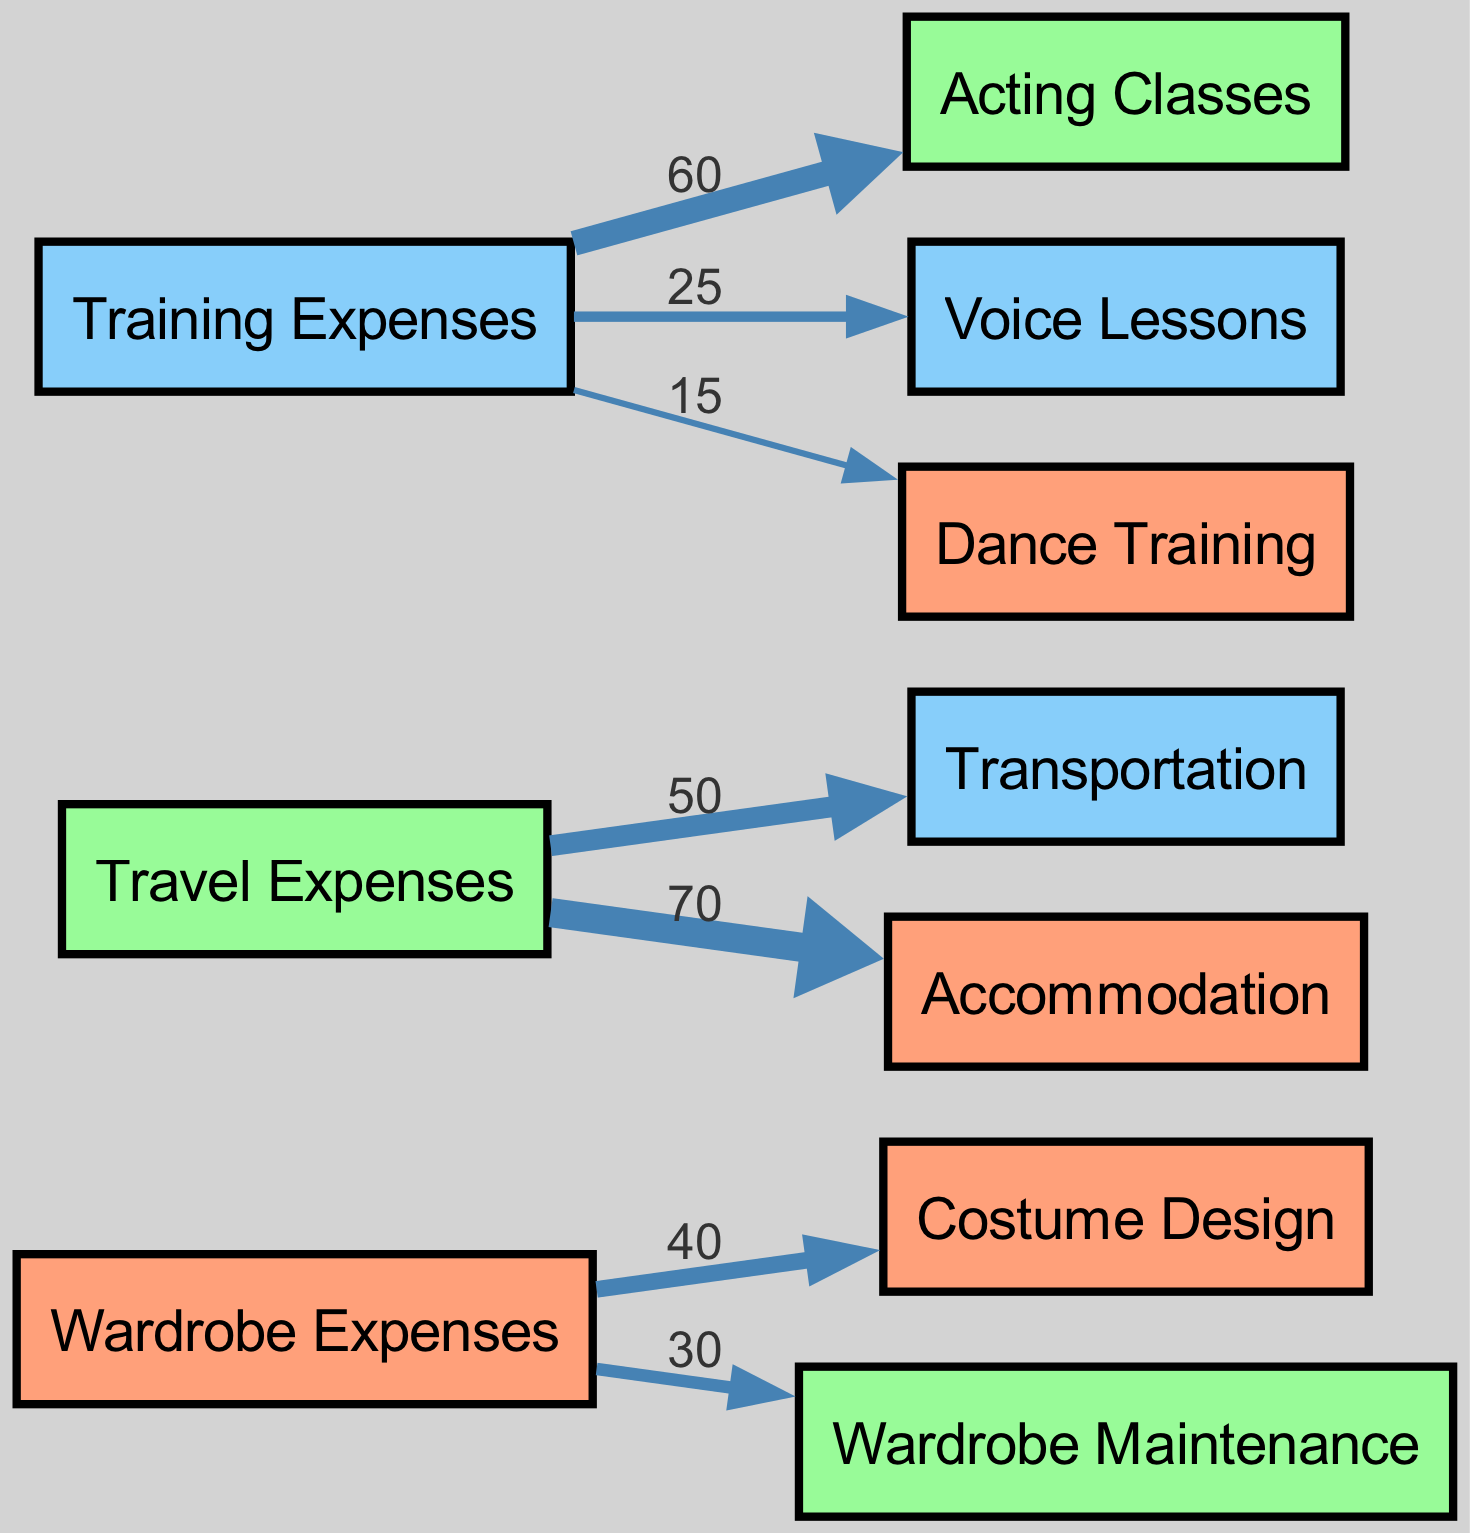What is the total expense for Training? To find the total expense for Training, we sum the values of all the linked nodes from the Training node, which are Acting Classes (60), Voice Lessons (25), and Dance Training (15). The total is 60 + 25 + 15 = 100.
Answer: 100 Which has a higher expense: Travel or Wardrobe? We compare the total expenses for Travel, which are Transportation (50) and Accommodation (70), totaling 120, with Wardrobe expenses, which are Costume Design (40) and Wardrobe Maintenance (30), totaling 70. Since 120 is greater than 70, Travel has a higher expense.
Answer: Travel What is the value associated with Costume Design? The value directly linked to the Costume Design node can be found by looking at the edge connecting Wardrobe to Costume Design, which has a value of 40.
Answer: 40 How many nodes represent training-related expenses? We identify the nodes linked to the Training node which include Acting Classes, Voice Lessons, and Dance Training. This gives us a total of three nodes that represent training-related expenses.
Answer: 3 What is the relationship between Travel and Accommodation? The relationship is indicated through the edge that connects the Travel node to the Accommodation node, which shows a value of 70. This means that 70 units of expense flow from Travel to Accommodation.
Answer: 70 Which individual expense is the largest in the Diagram? To determine the largest individual expense, we compare all linked values. The values are 40 (Costume Design), 30 (Wardrobe Maintenance), 50 (Transportation), 70 (Accommodation), 60 (Acting Classes), 25 (Voice Lessons), and 15 (Dance Training). The highest value is 70, associated with Accommodation.
Answer: 70 How does the value of Voice Lessons compare to Dance Training? We compare the values of both nodes; Voice Lessons has a value of 25 and Dance Training has a value of 15. Since 25 is greater than 15, Voice Lessons has a higher value than Dance Training.
Answer: Voice Lessons Which category has more outgoing expenses: Wardrobe or Training? We count the outgoing expenses from both categories. Wardrobe has two outgoing expenses (Costume Design at 40 and Wardrobe Maintenance at 30, total 70), and Training has three outgoing expenses (Acting Classes at 60, Voice Lessons at 25, and Dance Training at 15, total 100). Therefore, Training has more outgoing expenses than Wardrobe.
Answer: Training 